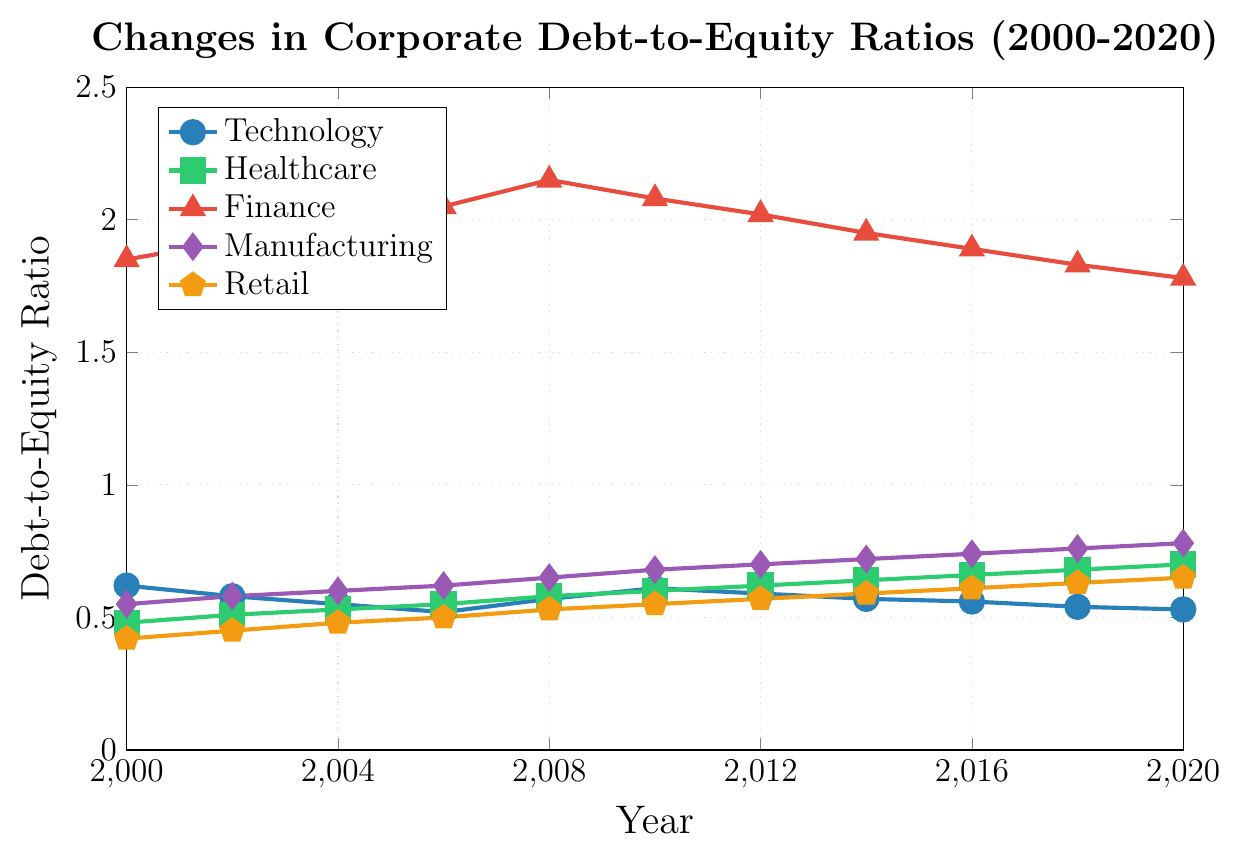What industry had the highest debt-to-equity ratio in 2020? Look at the 2020 data for all industries. The Finance industry has the highest value.
Answer: Finance Which industry consistently showed an increasing trend in debt-to-equity ratio from 2000 to 2020? Observe the trend lines of all industries from 2000 to 2020. Healthcare shows a consistent increase over the years.
Answer: Healthcare What year did the Retail industry have a debt-to-equity ratio of 0.50? Observe the Retail data points on the graph to find where the ratio is 0.50. This occurs in 2006.
Answer: 2006 Compare the debt-to-equity ratio of Technology and Manufacturing industries in 2010. Which one is higher? In 2010, the Technology ratio is 0.61 and Manufacturing is 0.68. Thus, Manufacturing is higher.
Answer: Manufacturing What is the difference in the debt-to-equity ratio of Finance and Healthcare industries in 2008? In 2008, Finance is at 2.15 and Healthcare is 0.58. The difference is 2.15 - 0.58 = 1.57.
Answer: 1.57 Which two industries had the lowest debt-to-equity ratios in 2016, and what were those ratios? In 2016, Technology and Healthcare have the lowest ratios: Technology is 0.56 and Healthcare is 0.66.
Answer: Technology: 0.56, Healthcare: 0.66 In which year did Manufacturing first surpass a debt-to-equity ratio of 0.70? Check the Manufacturing trend and find the year it first exceeds 0.70. This happened in 2012.
Answer: 2012 How does the retail industry's debt-to-equity ratio change from 2000 to 2020? Observe the Retail trend from 2000 (0.42) to 2020 (0.65). The ratio increases over this period.
Answer: Increases What is the average debt-to-equity ratio of the Finance industry from 2000 to 2020? Sum the Finance ratios over the years and divide by the number of data points: (1.85 + 1.92 + 1.98 + 2.05 + 2.15 + 2.08 + 2.02 + 1.95 + 1.89 + 1.83 + 1.78) / 11 = 1.97.
Answer: 1.97 